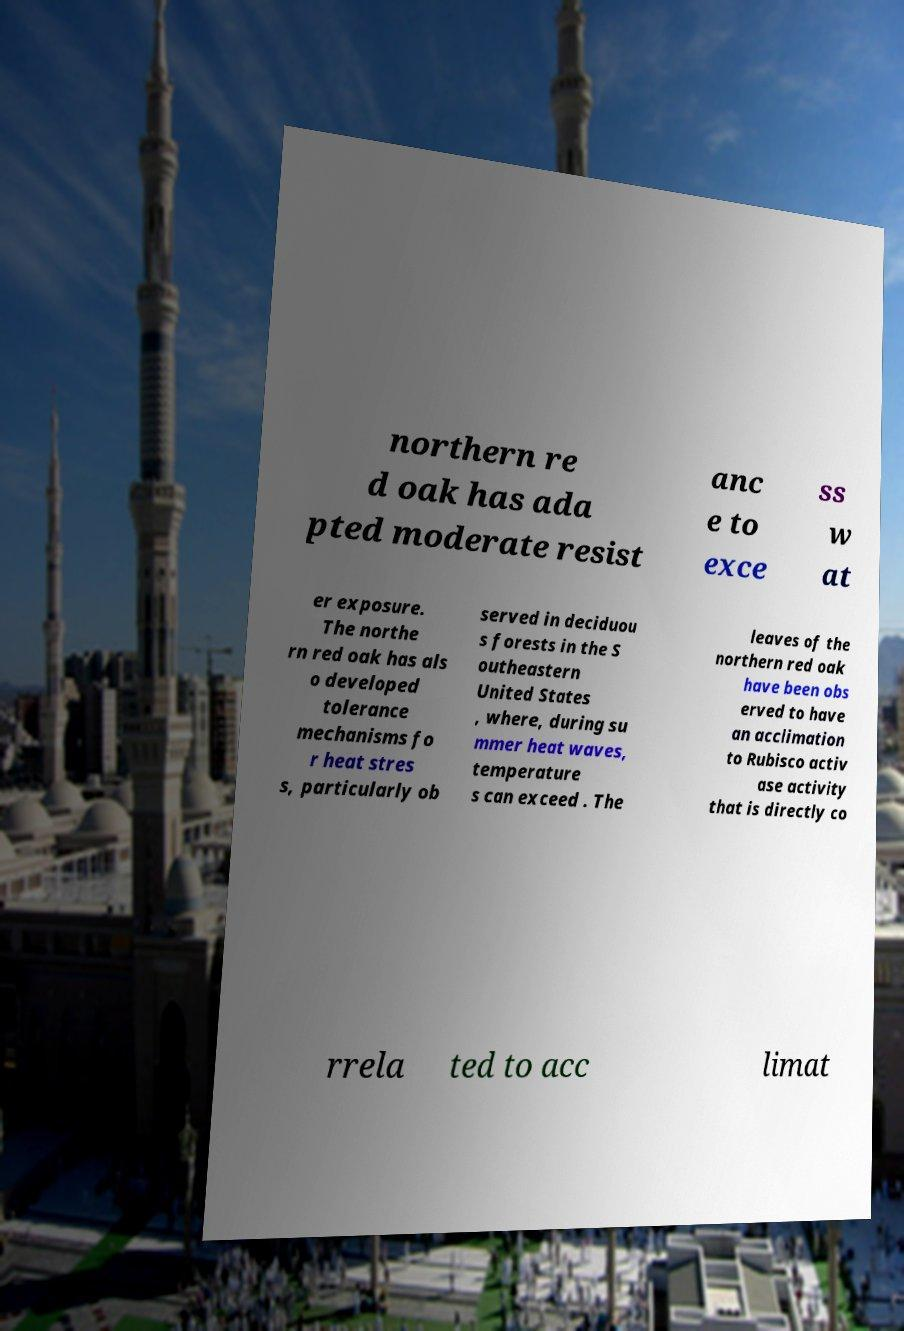Please identify and transcribe the text found in this image. northern re d oak has ada pted moderate resist anc e to exce ss w at er exposure. The northe rn red oak has als o developed tolerance mechanisms fo r heat stres s, particularly ob served in deciduou s forests in the S outheastern United States , where, during su mmer heat waves, temperature s can exceed . The leaves of the northern red oak have been obs erved to have an acclimation to Rubisco activ ase activity that is directly co rrela ted to acc limat 